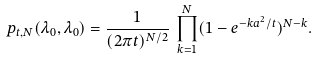<formula> <loc_0><loc_0><loc_500><loc_500>p _ { t , N } ( \lambda _ { 0 } , \lambda _ { 0 } ) = { \frac { 1 } { ( 2 \pi t ) ^ { N / 2 } } } \, \prod _ { k = 1 } ^ { N } ( 1 - e ^ { - k a ^ { 2 } / t } ) ^ { N - k } .</formula> 